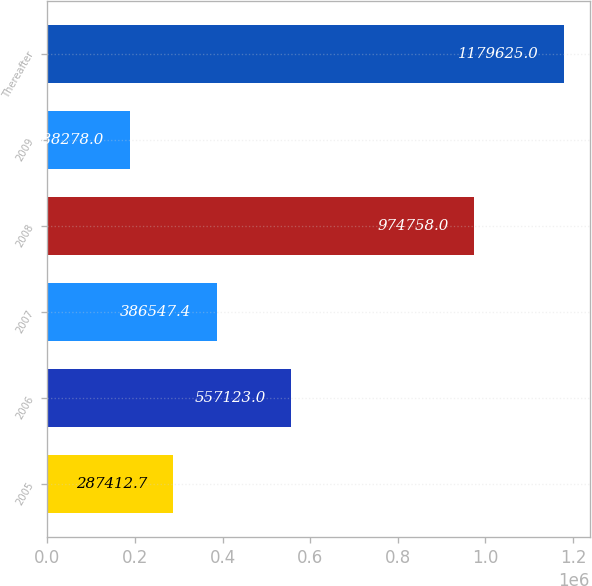Convert chart. <chart><loc_0><loc_0><loc_500><loc_500><bar_chart><fcel>2005<fcel>2006<fcel>2007<fcel>2008<fcel>2009<fcel>Thereafter<nl><fcel>287413<fcel>557123<fcel>386547<fcel>974758<fcel>188278<fcel>1.17962e+06<nl></chart> 